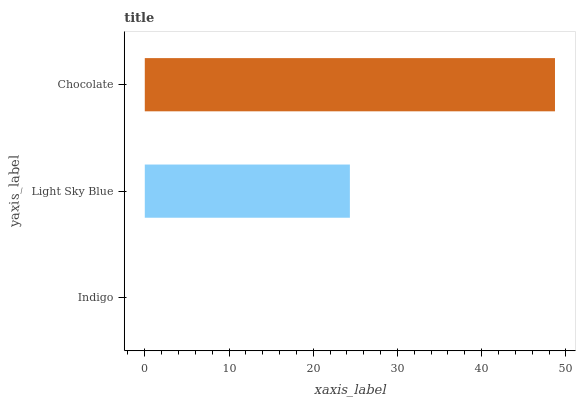Is Indigo the minimum?
Answer yes or no. Yes. Is Chocolate the maximum?
Answer yes or no. Yes. Is Light Sky Blue the minimum?
Answer yes or no. No. Is Light Sky Blue the maximum?
Answer yes or no. No. Is Light Sky Blue greater than Indigo?
Answer yes or no. Yes. Is Indigo less than Light Sky Blue?
Answer yes or no. Yes. Is Indigo greater than Light Sky Blue?
Answer yes or no. No. Is Light Sky Blue less than Indigo?
Answer yes or no. No. Is Light Sky Blue the high median?
Answer yes or no. Yes. Is Light Sky Blue the low median?
Answer yes or no. Yes. Is Chocolate the high median?
Answer yes or no. No. Is Indigo the low median?
Answer yes or no. No. 